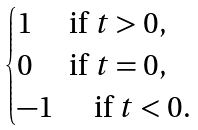<formula> <loc_0><loc_0><loc_500><loc_500>\begin{cases} 1 \quad \text { if } t > 0 , \\ 0 \quad \text { if } t = 0 , \\ - 1 \quad \, \text { if } t < 0 . \end{cases}</formula> 